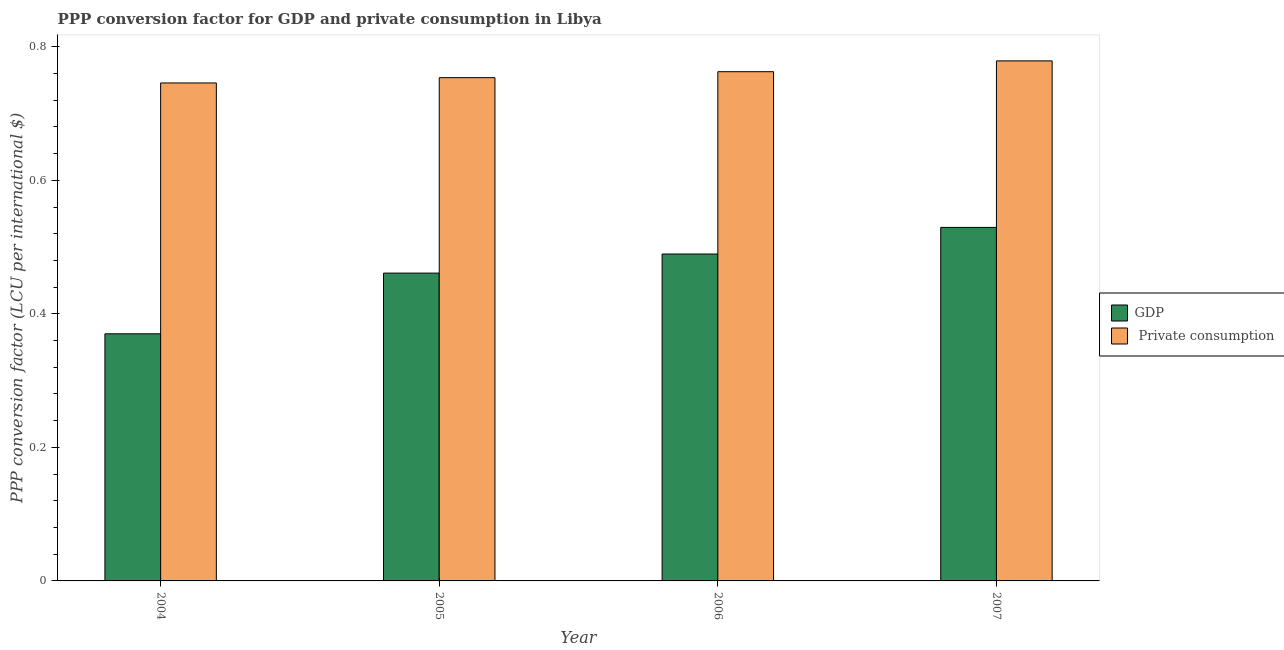How many different coloured bars are there?
Your answer should be very brief. 2. How many groups of bars are there?
Give a very brief answer. 4. Are the number of bars per tick equal to the number of legend labels?
Your answer should be very brief. Yes. Are the number of bars on each tick of the X-axis equal?
Keep it short and to the point. Yes. In how many cases, is the number of bars for a given year not equal to the number of legend labels?
Keep it short and to the point. 0. What is the ppp conversion factor for private consumption in 2007?
Ensure brevity in your answer.  0.78. Across all years, what is the maximum ppp conversion factor for gdp?
Ensure brevity in your answer.  0.53. Across all years, what is the minimum ppp conversion factor for gdp?
Your answer should be very brief. 0.37. In which year was the ppp conversion factor for gdp maximum?
Make the answer very short. 2007. What is the total ppp conversion factor for private consumption in the graph?
Offer a terse response. 3.04. What is the difference between the ppp conversion factor for private consumption in 2006 and that in 2007?
Keep it short and to the point. -0.02. What is the difference between the ppp conversion factor for gdp in 2005 and the ppp conversion factor for private consumption in 2006?
Offer a very short reply. -0.03. What is the average ppp conversion factor for gdp per year?
Give a very brief answer. 0.46. In the year 2006, what is the difference between the ppp conversion factor for gdp and ppp conversion factor for private consumption?
Your answer should be compact. 0. What is the ratio of the ppp conversion factor for private consumption in 2006 to that in 2007?
Your answer should be very brief. 0.98. Is the ppp conversion factor for gdp in 2005 less than that in 2006?
Provide a succinct answer. Yes. What is the difference between the highest and the second highest ppp conversion factor for private consumption?
Offer a very short reply. 0.02. What is the difference between the highest and the lowest ppp conversion factor for private consumption?
Your answer should be compact. 0.03. In how many years, is the ppp conversion factor for private consumption greater than the average ppp conversion factor for private consumption taken over all years?
Make the answer very short. 2. What does the 2nd bar from the left in 2006 represents?
Your answer should be very brief.  Private consumption. What does the 1st bar from the right in 2007 represents?
Your answer should be very brief.  Private consumption. What is the difference between two consecutive major ticks on the Y-axis?
Offer a terse response. 0.2. Does the graph contain grids?
Your answer should be compact. No. How many legend labels are there?
Your response must be concise. 2. What is the title of the graph?
Your answer should be very brief. PPP conversion factor for GDP and private consumption in Libya. Does "Frequency of shipment arrival" appear as one of the legend labels in the graph?
Keep it short and to the point. No. What is the label or title of the X-axis?
Offer a terse response. Year. What is the label or title of the Y-axis?
Offer a very short reply. PPP conversion factor (LCU per international $). What is the PPP conversion factor (LCU per international $) of GDP in 2004?
Keep it short and to the point. 0.37. What is the PPP conversion factor (LCU per international $) of  Private consumption in 2004?
Offer a terse response. 0.75. What is the PPP conversion factor (LCU per international $) in GDP in 2005?
Make the answer very short. 0.46. What is the PPP conversion factor (LCU per international $) in  Private consumption in 2005?
Offer a terse response. 0.75. What is the PPP conversion factor (LCU per international $) of GDP in 2006?
Ensure brevity in your answer.  0.49. What is the PPP conversion factor (LCU per international $) of  Private consumption in 2006?
Your answer should be very brief. 0.76. What is the PPP conversion factor (LCU per international $) in GDP in 2007?
Your answer should be very brief. 0.53. What is the PPP conversion factor (LCU per international $) in  Private consumption in 2007?
Your answer should be compact. 0.78. Across all years, what is the maximum PPP conversion factor (LCU per international $) in GDP?
Offer a terse response. 0.53. Across all years, what is the maximum PPP conversion factor (LCU per international $) in  Private consumption?
Ensure brevity in your answer.  0.78. Across all years, what is the minimum PPP conversion factor (LCU per international $) in GDP?
Provide a succinct answer. 0.37. Across all years, what is the minimum PPP conversion factor (LCU per international $) of  Private consumption?
Provide a short and direct response. 0.75. What is the total PPP conversion factor (LCU per international $) of GDP in the graph?
Offer a terse response. 1.85. What is the total PPP conversion factor (LCU per international $) of  Private consumption in the graph?
Give a very brief answer. 3.04. What is the difference between the PPP conversion factor (LCU per international $) in GDP in 2004 and that in 2005?
Keep it short and to the point. -0.09. What is the difference between the PPP conversion factor (LCU per international $) in  Private consumption in 2004 and that in 2005?
Offer a very short reply. -0.01. What is the difference between the PPP conversion factor (LCU per international $) in GDP in 2004 and that in 2006?
Make the answer very short. -0.12. What is the difference between the PPP conversion factor (LCU per international $) of  Private consumption in 2004 and that in 2006?
Give a very brief answer. -0.02. What is the difference between the PPP conversion factor (LCU per international $) in GDP in 2004 and that in 2007?
Keep it short and to the point. -0.16. What is the difference between the PPP conversion factor (LCU per international $) in  Private consumption in 2004 and that in 2007?
Offer a terse response. -0.03. What is the difference between the PPP conversion factor (LCU per international $) in GDP in 2005 and that in 2006?
Your answer should be very brief. -0.03. What is the difference between the PPP conversion factor (LCU per international $) in  Private consumption in 2005 and that in 2006?
Offer a terse response. -0.01. What is the difference between the PPP conversion factor (LCU per international $) in GDP in 2005 and that in 2007?
Provide a short and direct response. -0.07. What is the difference between the PPP conversion factor (LCU per international $) in  Private consumption in 2005 and that in 2007?
Ensure brevity in your answer.  -0.03. What is the difference between the PPP conversion factor (LCU per international $) of GDP in 2006 and that in 2007?
Make the answer very short. -0.04. What is the difference between the PPP conversion factor (LCU per international $) in  Private consumption in 2006 and that in 2007?
Provide a short and direct response. -0.02. What is the difference between the PPP conversion factor (LCU per international $) of GDP in 2004 and the PPP conversion factor (LCU per international $) of  Private consumption in 2005?
Your answer should be very brief. -0.38. What is the difference between the PPP conversion factor (LCU per international $) of GDP in 2004 and the PPP conversion factor (LCU per international $) of  Private consumption in 2006?
Your response must be concise. -0.39. What is the difference between the PPP conversion factor (LCU per international $) in GDP in 2004 and the PPP conversion factor (LCU per international $) in  Private consumption in 2007?
Make the answer very short. -0.41. What is the difference between the PPP conversion factor (LCU per international $) of GDP in 2005 and the PPP conversion factor (LCU per international $) of  Private consumption in 2006?
Keep it short and to the point. -0.3. What is the difference between the PPP conversion factor (LCU per international $) in GDP in 2005 and the PPP conversion factor (LCU per international $) in  Private consumption in 2007?
Your response must be concise. -0.32. What is the difference between the PPP conversion factor (LCU per international $) in GDP in 2006 and the PPP conversion factor (LCU per international $) in  Private consumption in 2007?
Offer a very short reply. -0.29. What is the average PPP conversion factor (LCU per international $) in GDP per year?
Offer a very short reply. 0.46. What is the average PPP conversion factor (LCU per international $) of  Private consumption per year?
Your response must be concise. 0.76. In the year 2004, what is the difference between the PPP conversion factor (LCU per international $) in GDP and PPP conversion factor (LCU per international $) in  Private consumption?
Provide a succinct answer. -0.38. In the year 2005, what is the difference between the PPP conversion factor (LCU per international $) of GDP and PPP conversion factor (LCU per international $) of  Private consumption?
Your answer should be compact. -0.29. In the year 2006, what is the difference between the PPP conversion factor (LCU per international $) in GDP and PPP conversion factor (LCU per international $) in  Private consumption?
Offer a terse response. -0.27. In the year 2007, what is the difference between the PPP conversion factor (LCU per international $) in GDP and PPP conversion factor (LCU per international $) in  Private consumption?
Your answer should be very brief. -0.25. What is the ratio of the PPP conversion factor (LCU per international $) of GDP in 2004 to that in 2005?
Make the answer very short. 0.8. What is the ratio of the PPP conversion factor (LCU per international $) in  Private consumption in 2004 to that in 2005?
Your answer should be very brief. 0.99. What is the ratio of the PPP conversion factor (LCU per international $) of GDP in 2004 to that in 2006?
Offer a terse response. 0.76. What is the ratio of the PPP conversion factor (LCU per international $) of  Private consumption in 2004 to that in 2006?
Your response must be concise. 0.98. What is the ratio of the PPP conversion factor (LCU per international $) in GDP in 2004 to that in 2007?
Provide a short and direct response. 0.7. What is the ratio of the PPP conversion factor (LCU per international $) in  Private consumption in 2004 to that in 2007?
Provide a short and direct response. 0.96. What is the ratio of the PPP conversion factor (LCU per international $) of GDP in 2005 to that in 2006?
Your answer should be very brief. 0.94. What is the ratio of the PPP conversion factor (LCU per international $) in  Private consumption in 2005 to that in 2006?
Your response must be concise. 0.99. What is the ratio of the PPP conversion factor (LCU per international $) in GDP in 2005 to that in 2007?
Provide a short and direct response. 0.87. What is the ratio of the PPP conversion factor (LCU per international $) in  Private consumption in 2005 to that in 2007?
Your response must be concise. 0.97. What is the ratio of the PPP conversion factor (LCU per international $) in GDP in 2006 to that in 2007?
Keep it short and to the point. 0.92. What is the ratio of the PPP conversion factor (LCU per international $) in  Private consumption in 2006 to that in 2007?
Offer a terse response. 0.98. What is the difference between the highest and the second highest PPP conversion factor (LCU per international $) in GDP?
Make the answer very short. 0.04. What is the difference between the highest and the second highest PPP conversion factor (LCU per international $) of  Private consumption?
Give a very brief answer. 0.02. What is the difference between the highest and the lowest PPP conversion factor (LCU per international $) of GDP?
Your answer should be very brief. 0.16. What is the difference between the highest and the lowest PPP conversion factor (LCU per international $) of  Private consumption?
Your answer should be very brief. 0.03. 